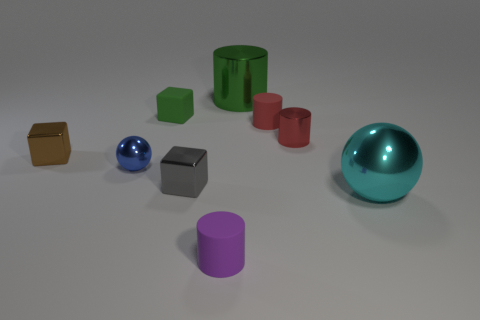Add 1 brown metal cylinders. How many objects exist? 10 Subtract all blocks. How many objects are left? 6 Add 5 green shiny cylinders. How many green shiny cylinders are left? 6 Add 9 large metallic cylinders. How many large metallic cylinders exist? 10 Subtract 0 red balls. How many objects are left? 9 Subtract all gray shiny things. Subtract all rubber things. How many objects are left? 5 